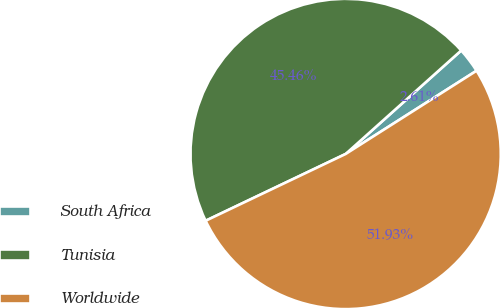Convert chart. <chart><loc_0><loc_0><loc_500><loc_500><pie_chart><fcel>South Africa<fcel>Tunisia<fcel>Worldwide<nl><fcel>2.61%<fcel>45.46%<fcel>51.93%<nl></chart> 